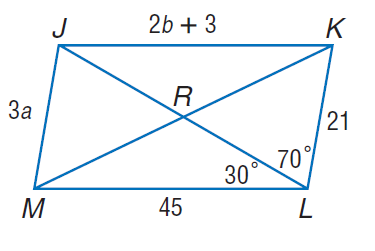Answer the mathemtical geometry problem and directly provide the correct option letter.
Question: Use parallelogram J K L M to find m \angle J M L if J K = 2 b + 3 and J M = 3 a.
Choices: A: 30 B: 70 C: 80 D: 100 C 